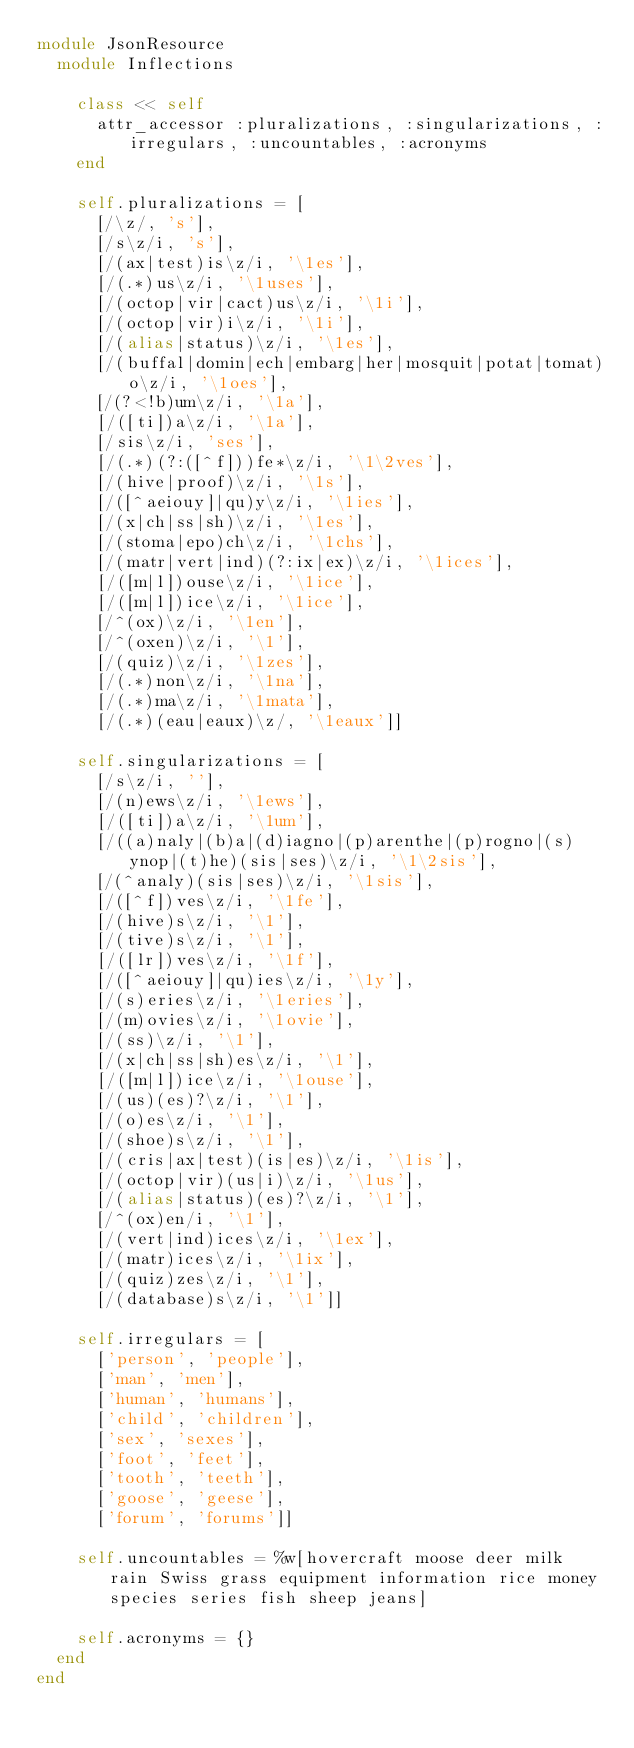<code> <loc_0><loc_0><loc_500><loc_500><_Ruby_>module JsonResource
  module Inflections
    
    class << self
      attr_accessor :pluralizations, :singularizations, :irregulars, :uncountables, :acronyms
    end
    
    self.pluralizations = [
      [/\z/, 's'],
      [/s\z/i, 's'],
      [/(ax|test)is\z/i, '\1es'],
      [/(.*)us\z/i, '\1uses'],
      [/(octop|vir|cact)us\z/i, '\1i'],
      [/(octop|vir)i\z/i, '\1i'],
      [/(alias|status)\z/i, '\1es'],
      [/(buffal|domin|ech|embarg|her|mosquit|potat|tomat)o\z/i, '\1oes'],
      [/(?<!b)um\z/i, '\1a'],
      [/([ti])a\z/i, '\1a'],
      [/sis\z/i, 'ses'],
      [/(.*)(?:([^f]))fe*\z/i, '\1\2ves'],
      [/(hive|proof)\z/i, '\1s'],
      [/([^aeiouy]|qu)y\z/i, '\1ies'],
      [/(x|ch|ss|sh)\z/i, '\1es'],
      [/(stoma|epo)ch\z/i, '\1chs'],
      [/(matr|vert|ind)(?:ix|ex)\z/i, '\1ices'],
      [/([m|l])ouse\z/i, '\1ice'],
      [/([m|l])ice\z/i, '\1ice'],
      [/^(ox)\z/i, '\1en'],
      [/^(oxen)\z/i, '\1'],
      [/(quiz)\z/i, '\1zes'],
      [/(.*)non\z/i, '\1na'],
      [/(.*)ma\z/i, '\1mata'],
      [/(.*)(eau|eaux)\z/, '\1eaux']]

    self.singularizations = [
      [/s\z/i, ''],
      [/(n)ews\z/i, '\1ews'],
      [/([ti])a\z/i, '\1um'],
      [/((a)naly|(b)a|(d)iagno|(p)arenthe|(p)rogno|(s)ynop|(t)he)(sis|ses)\z/i, '\1\2sis'],
      [/(^analy)(sis|ses)\z/i, '\1sis'],
      [/([^f])ves\z/i, '\1fe'],
      [/(hive)s\z/i, '\1'],
      [/(tive)s\z/i, '\1'],
      [/([lr])ves\z/i, '\1f'],
      [/([^aeiouy]|qu)ies\z/i, '\1y'],
      [/(s)eries\z/i, '\1eries'],
      [/(m)ovies\z/i, '\1ovie'],
      [/(ss)\z/i, '\1'],
      [/(x|ch|ss|sh)es\z/i, '\1'],
      [/([m|l])ice\z/i, '\1ouse'],
      [/(us)(es)?\z/i, '\1'],
      [/(o)es\z/i, '\1'],
      [/(shoe)s\z/i, '\1'],
      [/(cris|ax|test)(is|es)\z/i, '\1is'],
      [/(octop|vir)(us|i)\z/i, '\1us'],
      [/(alias|status)(es)?\z/i, '\1'],
      [/^(ox)en/i, '\1'],
      [/(vert|ind)ices\z/i, '\1ex'],
      [/(matr)ices\z/i, '\1ix'],
      [/(quiz)zes\z/i, '\1'],
      [/(database)s\z/i, '\1']]
    
    self.irregulars = [
      ['person', 'people'],
      ['man', 'men'],
      ['human', 'humans'],
      ['child', 'children'],
      ['sex', 'sexes'],
      ['foot', 'feet'],
      ['tooth', 'teeth'],
      ['goose', 'geese'],
      ['forum', 'forums']]

    self.uncountables = %w[hovercraft moose deer milk rain Swiss grass equipment information rice money species series fish sheep jeans]

    self.acronyms = {}
  end
end
</code> 